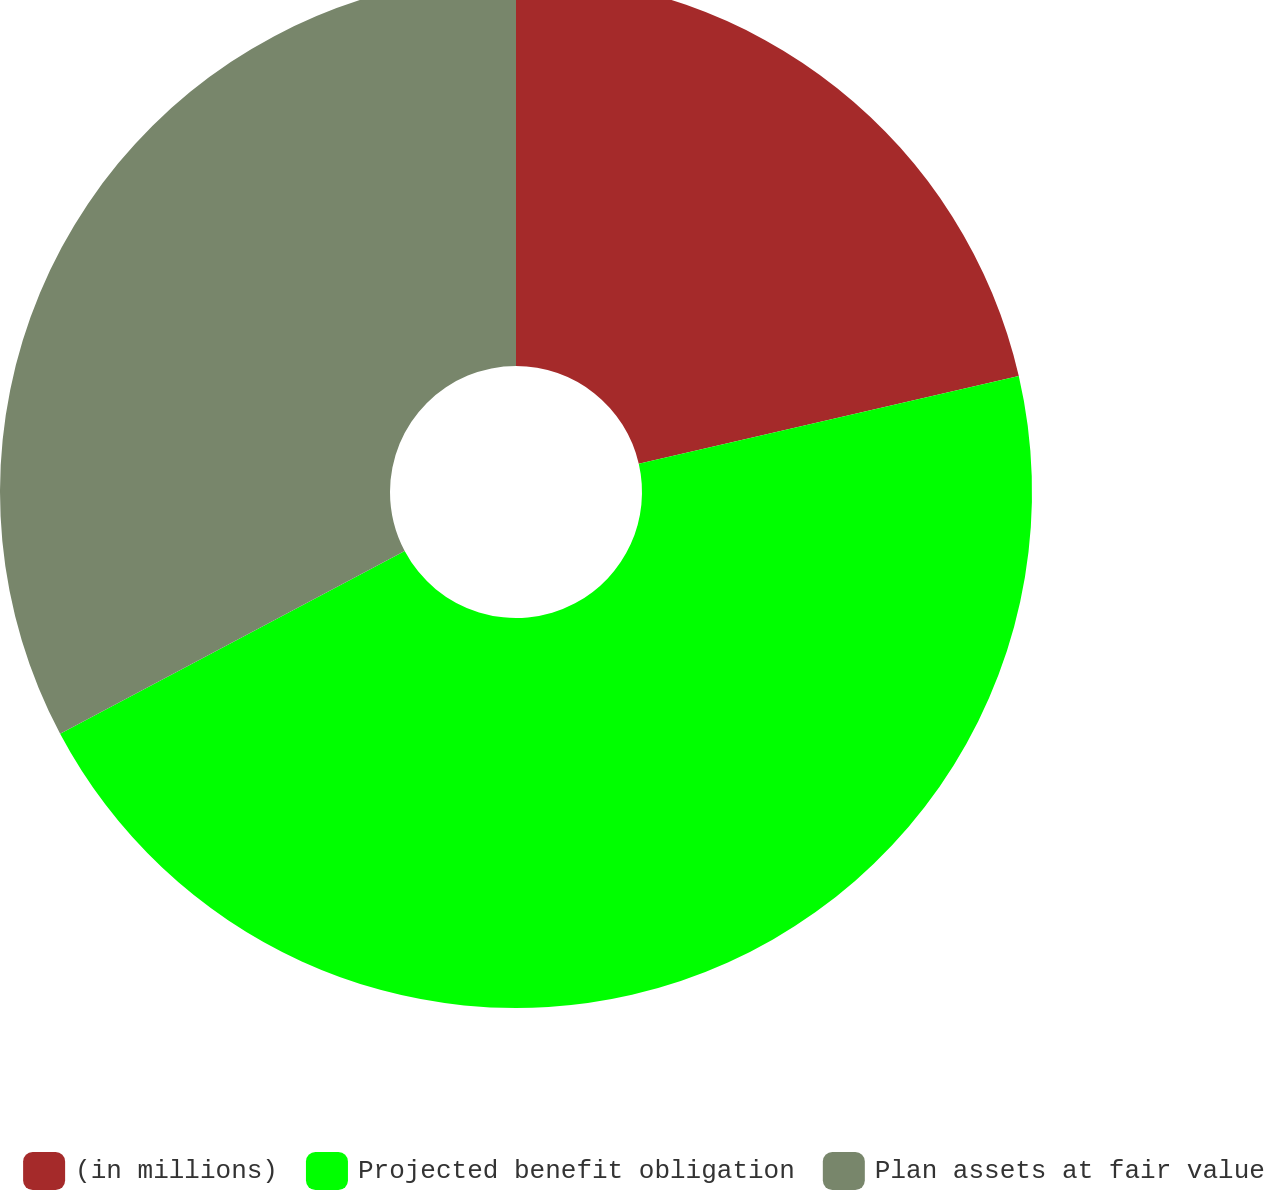<chart> <loc_0><loc_0><loc_500><loc_500><pie_chart><fcel>(in millions)<fcel>Projected benefit obligation<fcel>Plan assets at fair value<nl><fcel>21.39%<fcel>45.85%<fcel>32.76%<nl></chart> 